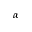Convert formula to latex. <formula><loc_0><loc_0><loc_500><loc_500>\alpha</formula> 